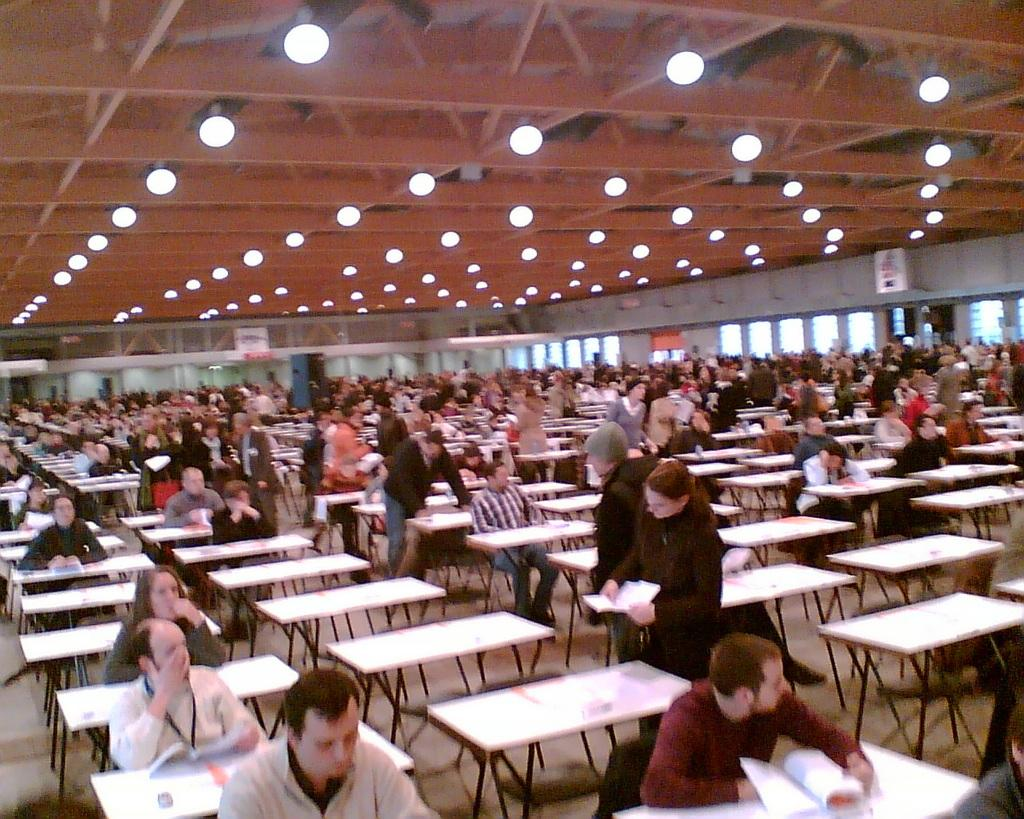What are the people in the image doing? The people in the image are sitting and standing near tables. What is visible at the top of the image? There is a roof visible at the top of the image. What can be used for illumination in the image? There are lights present in the image. What type of fruit is hanging from the roof in the image? There is no fruit hanging from the roof in the image. 